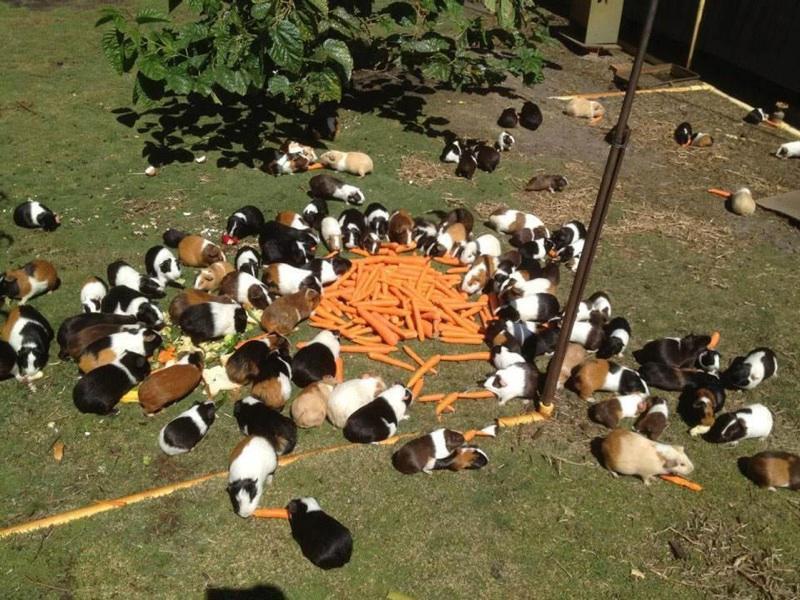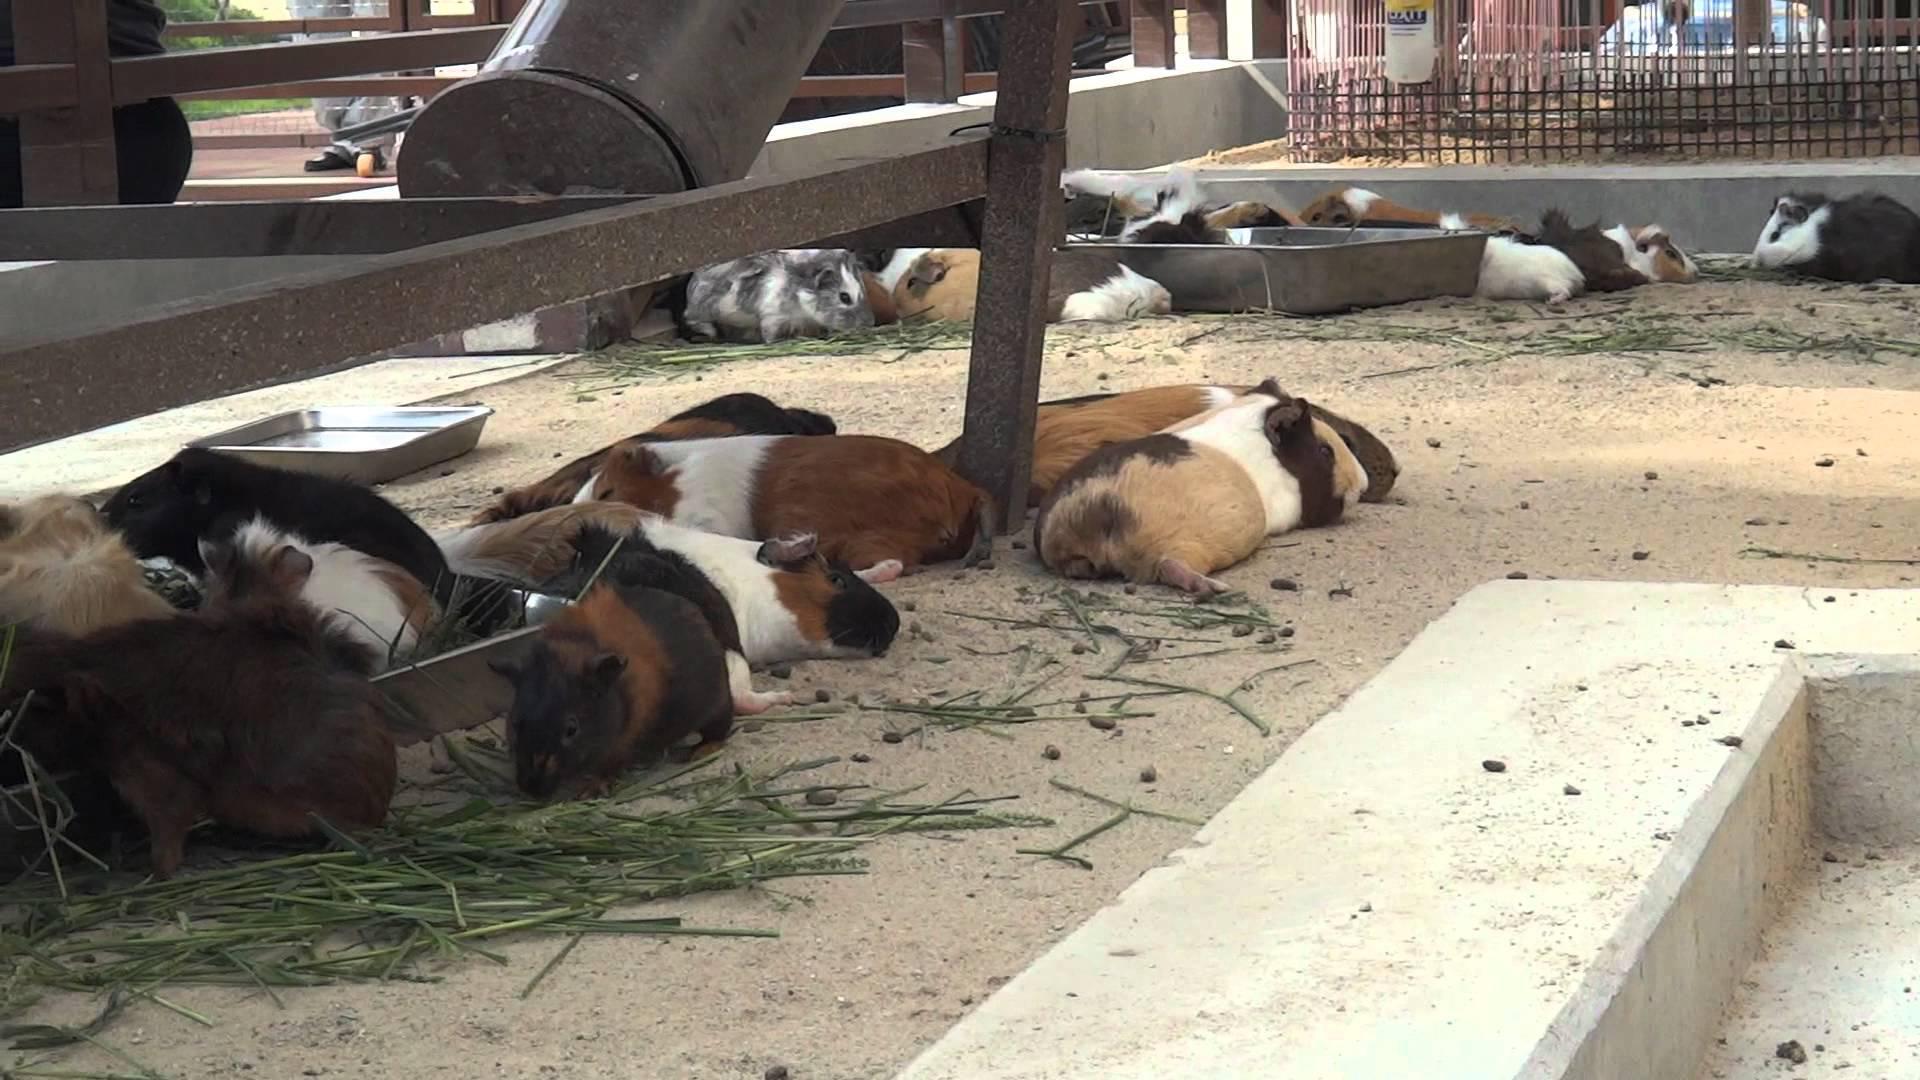The first image is the image on the left, the second image is the image on the right. Analyze the images presented: Is the assertion "An image shows guinea pigs gathered around something """"organic"""" to eat." valid? Answer yes or no. Yes. The first image is the image on the left, the second image is the image on the right. Examine the images to the left and right. Is the description "All of the guinea pigs are outside and some of them are eating greens." accurate? Answer yes or no. Yes. 